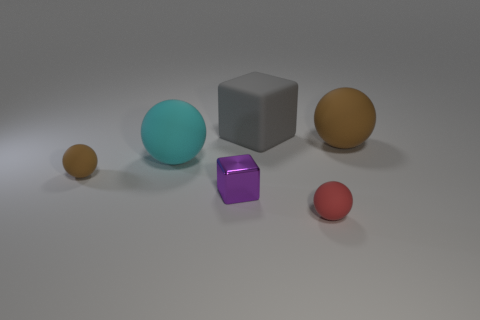The cyan thing that is made of the same material as the big block is what size?
Your answer should be compact. Large. Do the object that is in front of the purple shiny thing and the gray cube have the same size?
Give a very brief answer. No. There is a brown rubber thing that is left of the brown thing that is behind the brown matte object that is on the left side of the red sphere; what is its shape?
Your answer should be compact. Sphere. How many things are either tiny metal blocks or matte spheres that are behind the tiny brown rubber sphere?
Provide a short and direct response. 3. What is the size of the brown thing to the right of the large cube?
Your answer should be very brief. Large. Is the material of the red sphere the same as the large sphere to the right of the large gray matte block?
Ensure brevity in your answer.  Yes. There is a tiny sphere that is in front of the thing to the left of the big cyan thing; how many big cyan rubber balls are on the left side of it?
Your answer should be compact. 1. What number of green things are either small spheres or cubes?
Make the answer very short. 0. What is the shape of the small rubber object behind the red rubber thing?
Provide a succinct answer. Sphere. What is the color of the other rubber sphere that is the same size as the cyan ball?
Provide a short and direct response. Brown. 